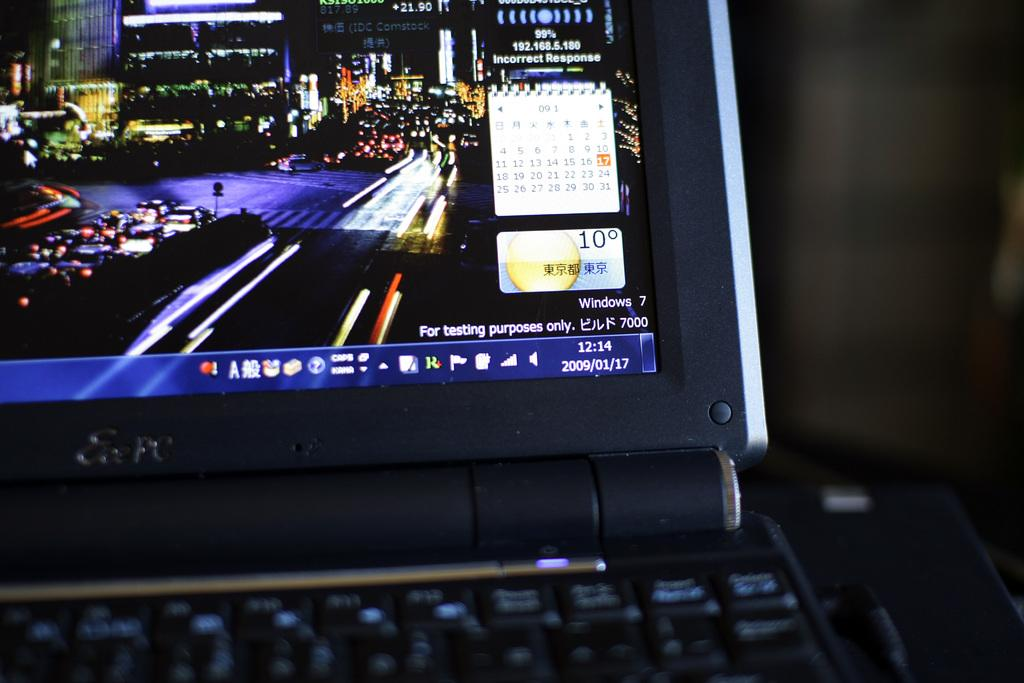<image>
Present a compact description of the photo's key features. The corner of a laptop screen running Windows 7 for testing purposes only. 